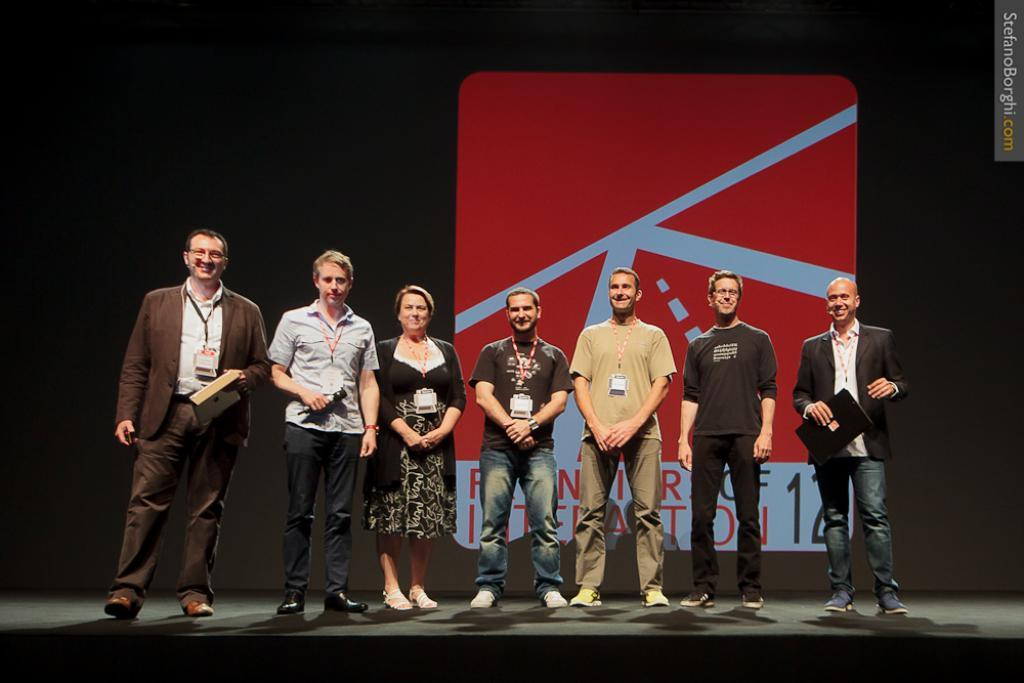What types of people are present in the image? There are men and women in the image. What are the men and women doing in the image? The men and women are standing. What are the men and women wearing in the image? The men and women are wearing clothes. What objects are the men and women holding in the image? The men and women have ID cards. What type of plate is being used to perform a trick in the image? There is no plate or trick present in the image. What surprise can be seen on the faces of the men and women in the image? There is no indication of surprise on the faces of the men and women in the image. 